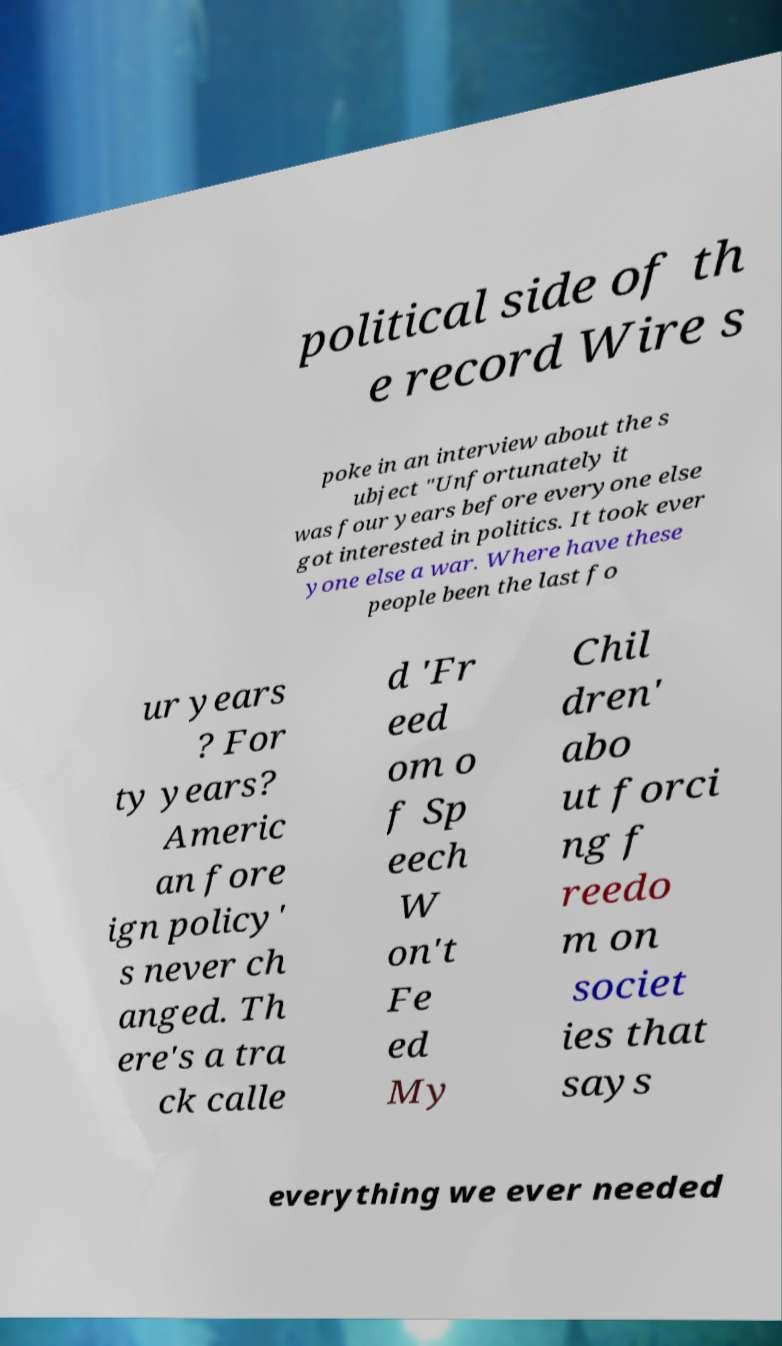What messages or text are displayed in this image? I need them in a readable, typed format. political side of th e record Wire s poke in an interview about the s ubject "Unfortunately it was four years before everyone else got interested in politics. It took ever yone else a war. Where have these people been the last fo ur years ? For ty years? Americ an fore ign policy' s never ch anged. Th ere's a tra ck calle d 'Fr eed om o f Sp eech W on't Fe ed My Chil dren' abo ut forci ng f reedo m on societ ies that says everything we ever needed 